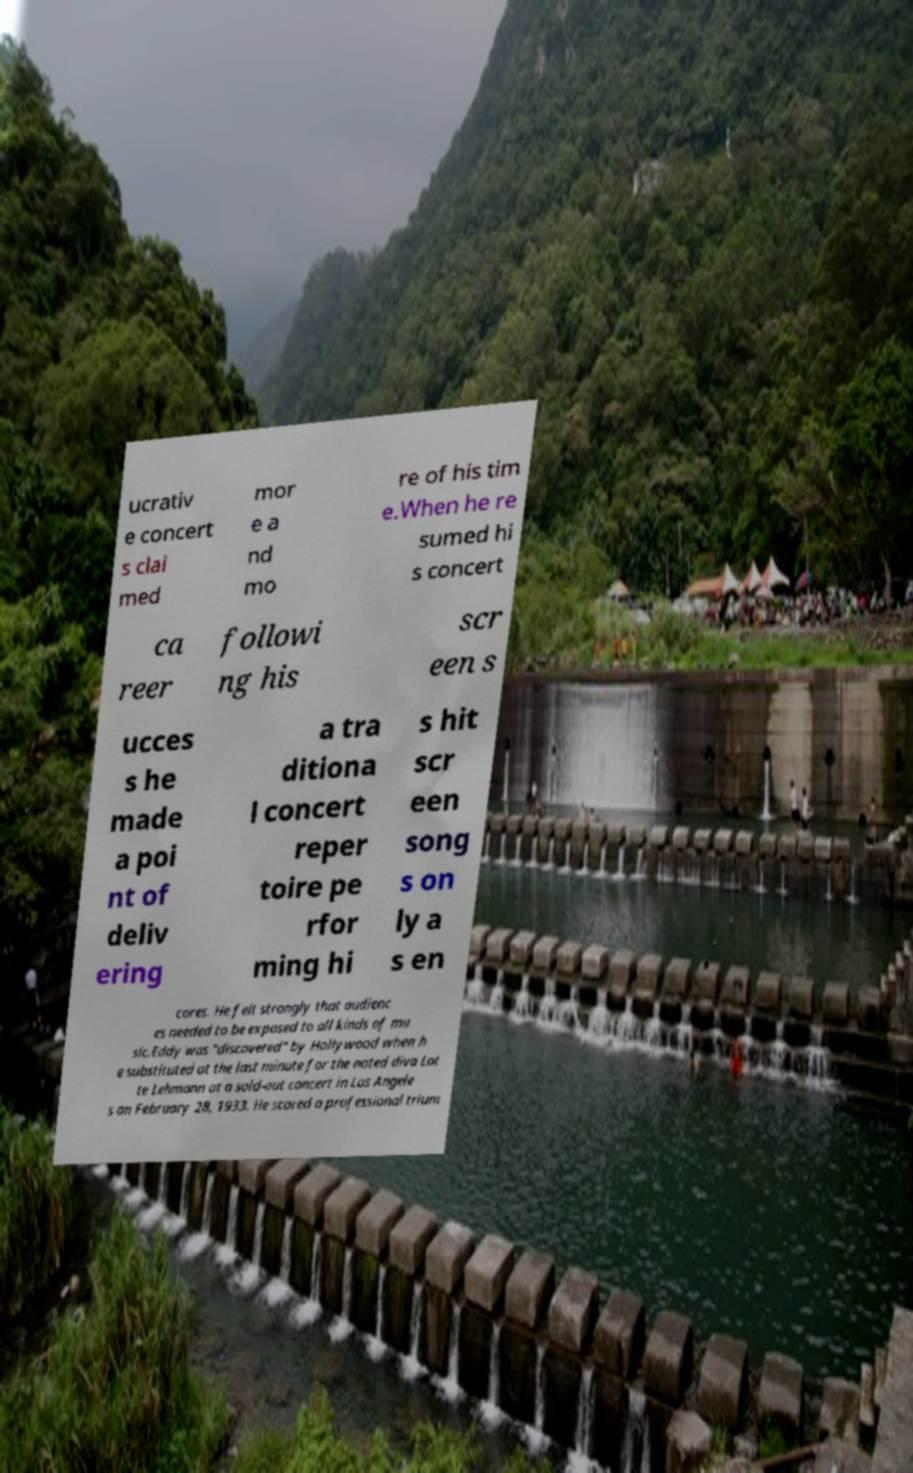I need the written content from this picture converted into text. Can you do that? ucrativ e concert s clai med mor e a nd mo re of his tim e.When he re sumed hi s concert ca reer followi ng his scr een s ucces s he made a poi nt of deliv ering a tra ditiona l concert reper toire pe rfor ming hi s hit scr een song s on ly a s en cores. He felt strongly that audienc es needed to be exposed to all kinds of mu sic.Eddy was "discovered" by Hollywood when h e substituted at the last minute for the noted diva Lot te Lehmann at a sold-out concert in Los Angele s on February 28, 1933. He scored a professional trium 